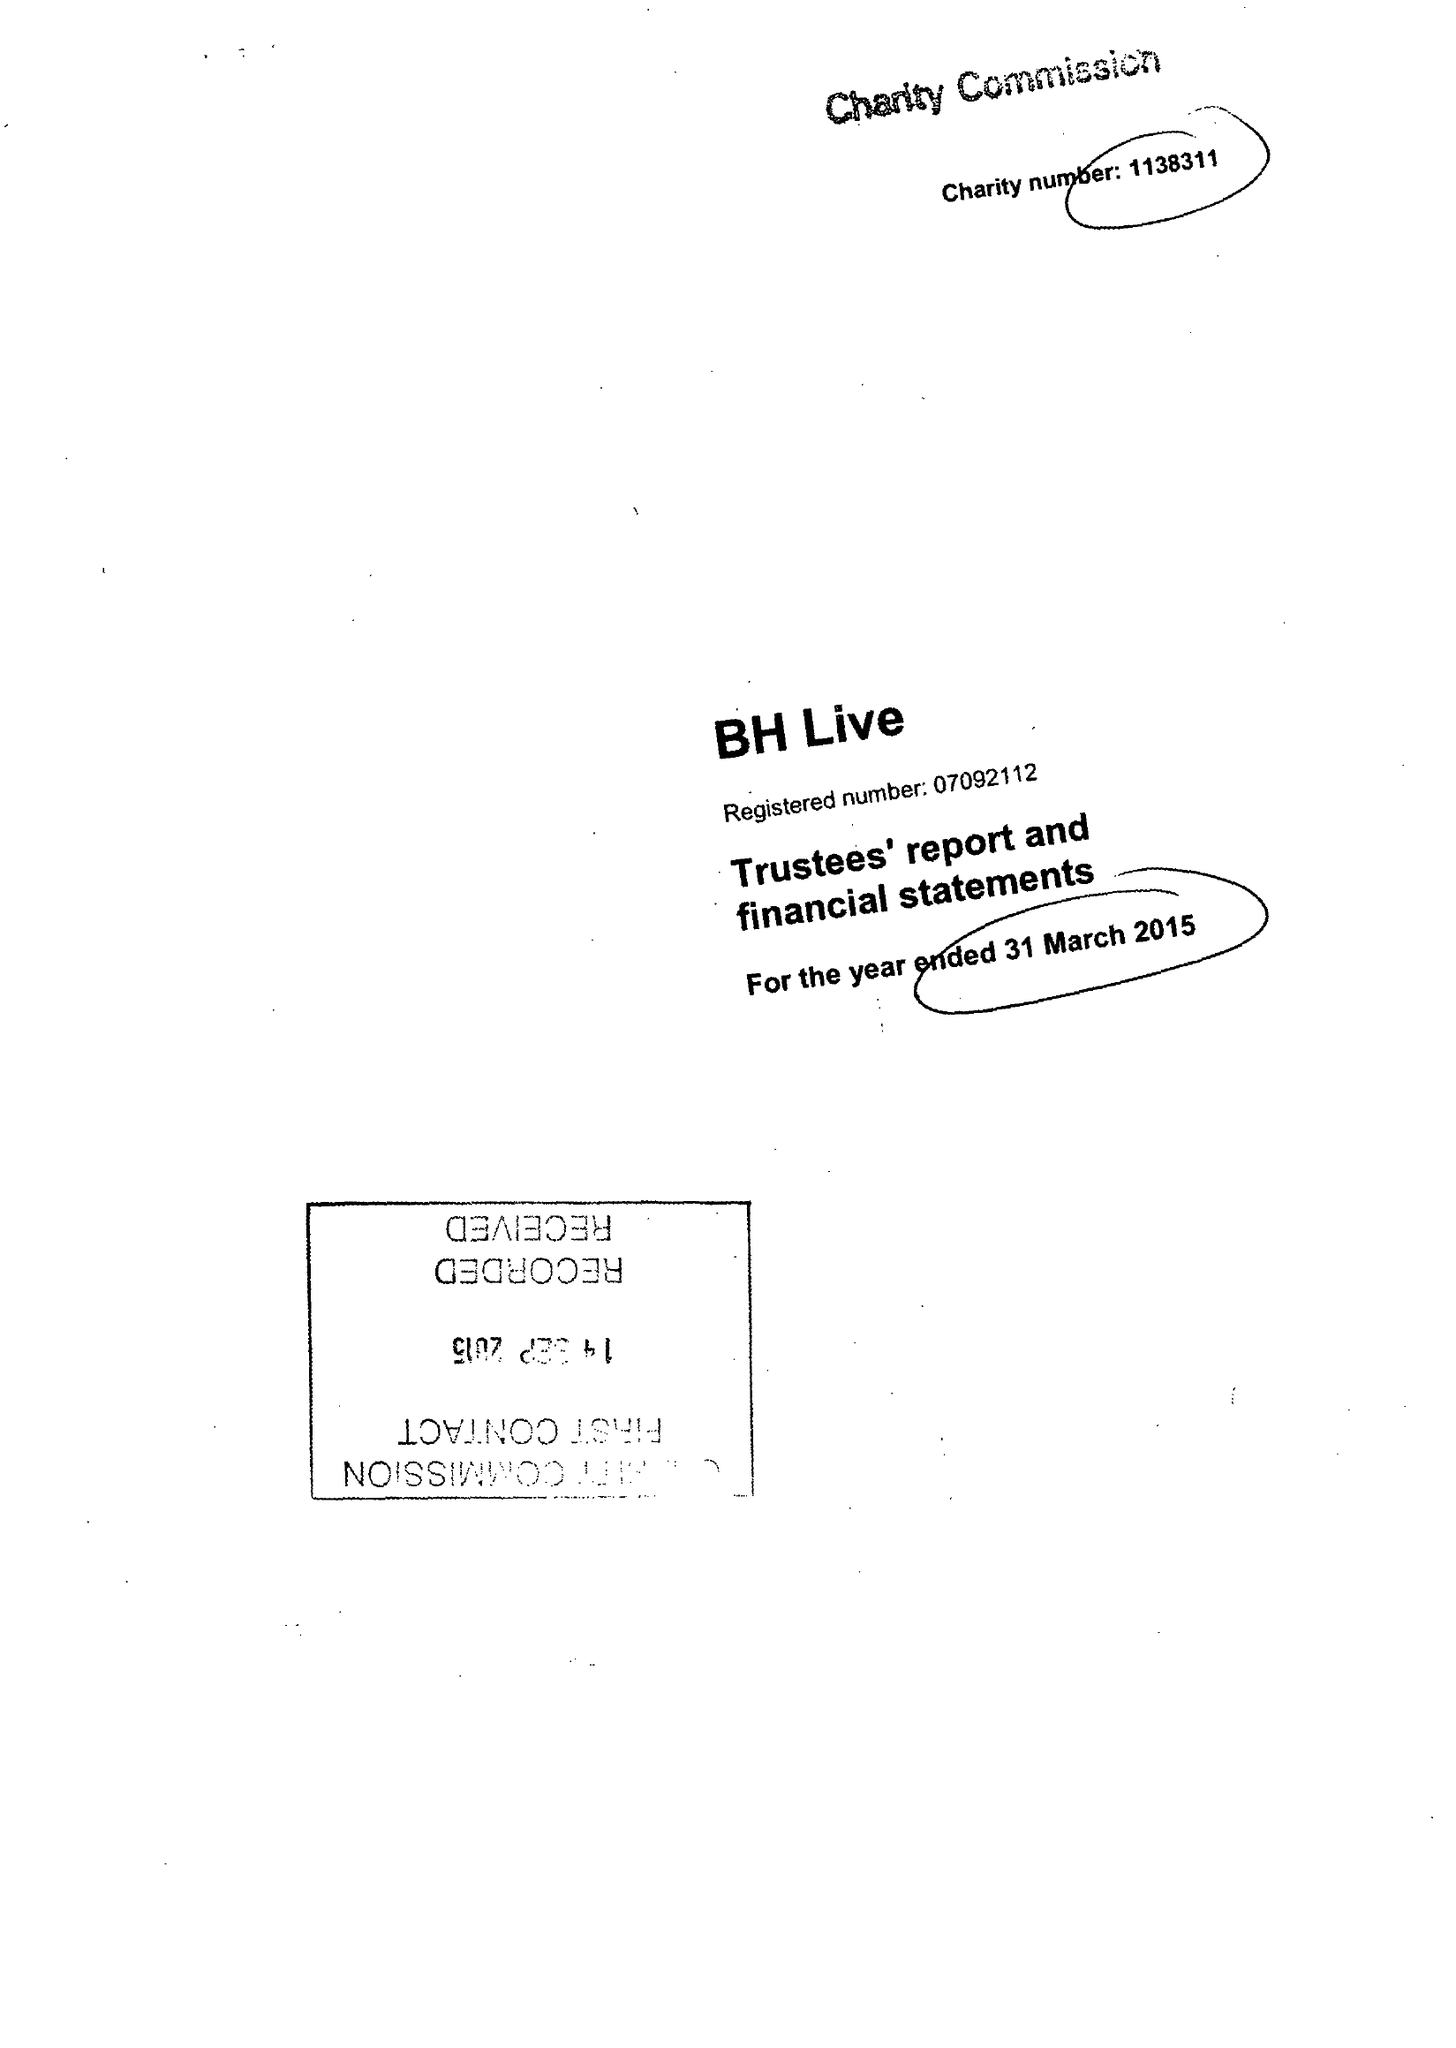What is the value for the income_annually_in_british_pounds?
Answer the question using a single word or phrase. 23757282.00 